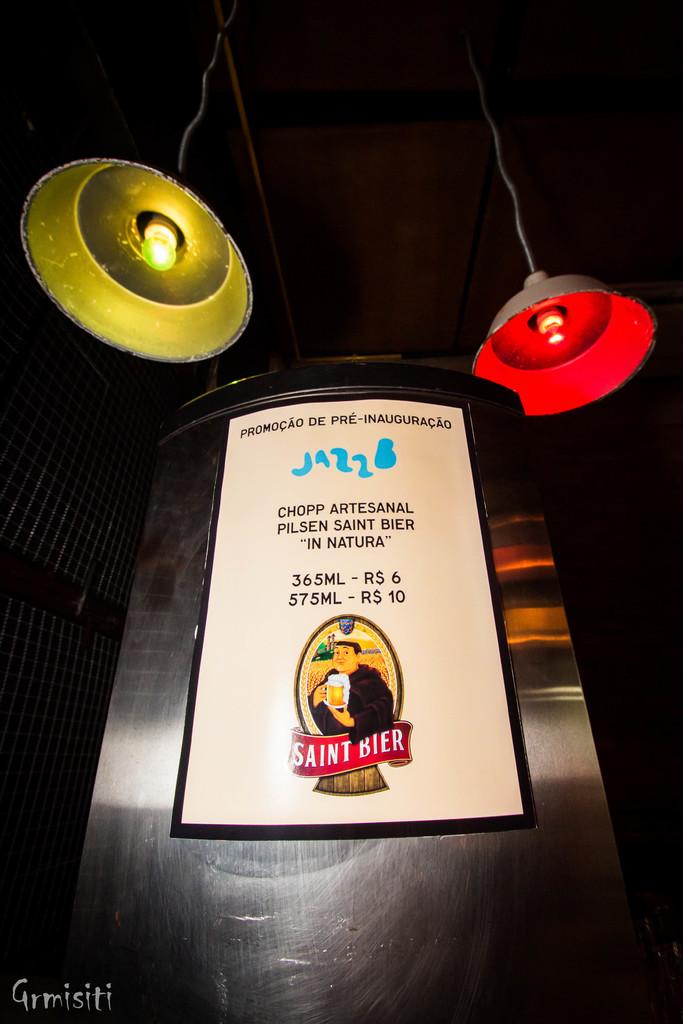How much for a 575ml?
Your response must be concise. $10. 